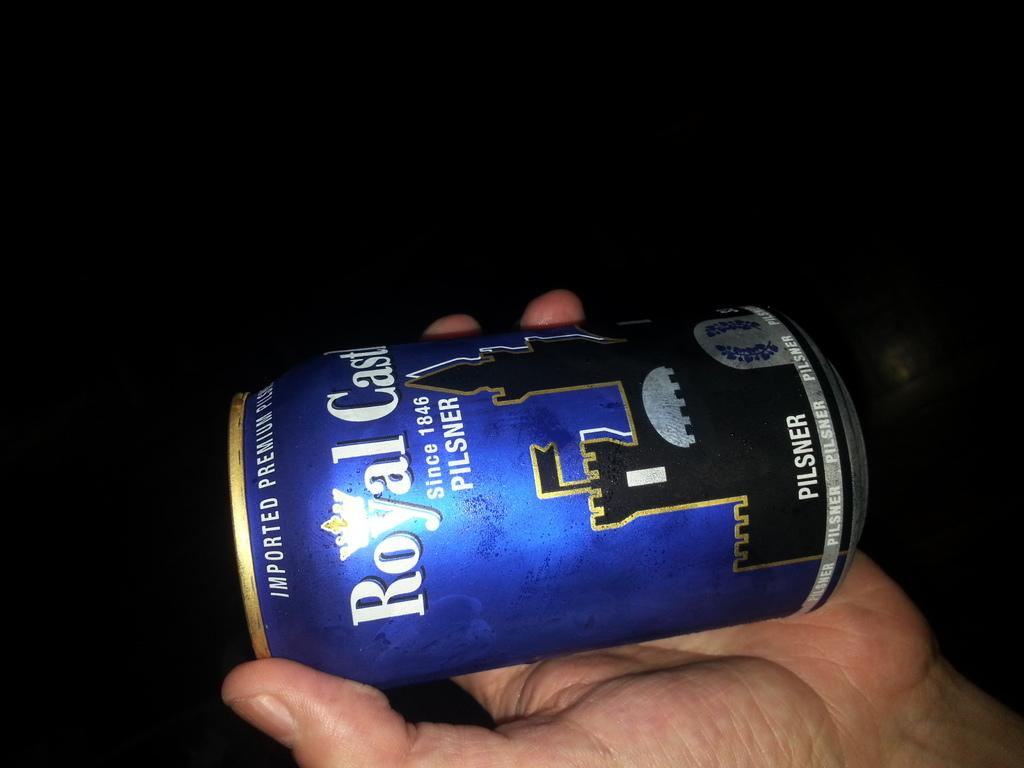<image>
Write a terse but informative summary of the picture. A can of Royal Castle pilsner features a dark castle on it. 